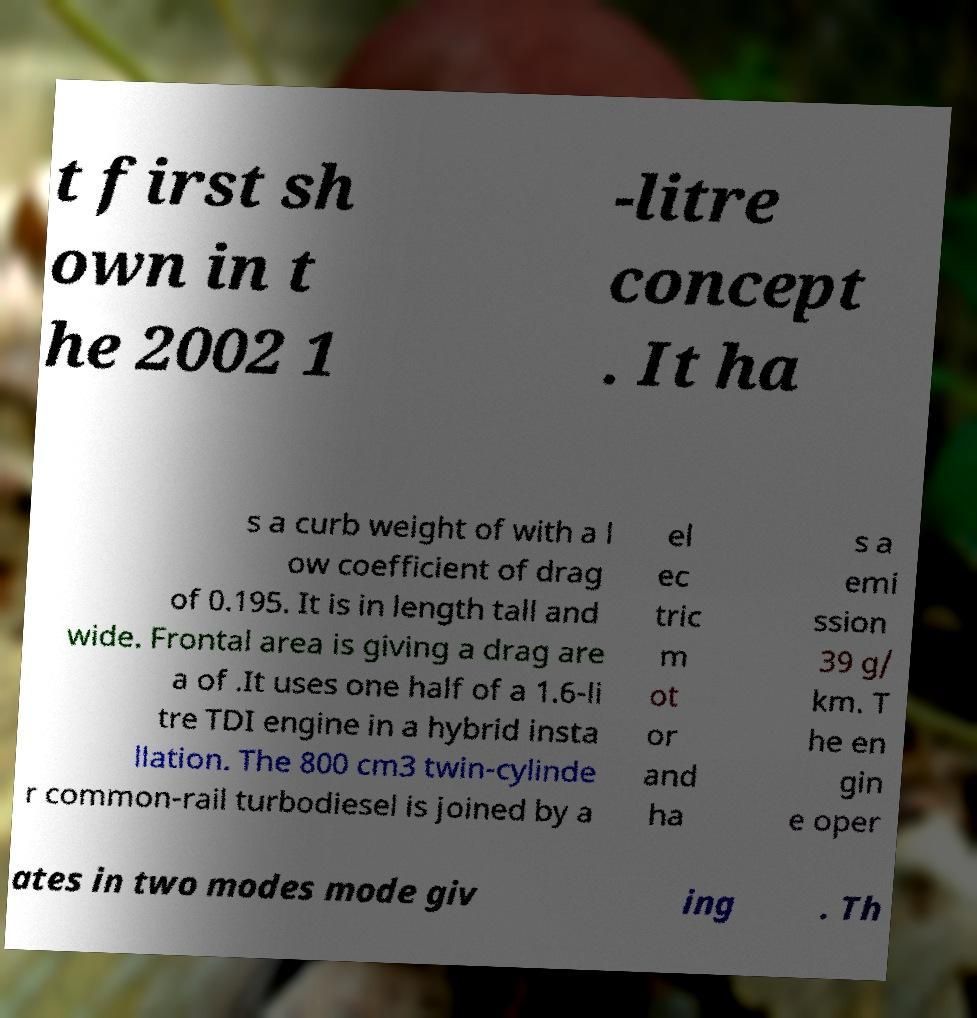Could you extract and type out the text from this image? t first sh own in t he 2002 1 -litre concept . It ha s a curb weight of with a l ow coefficient of drag of 0.195. It is in length tall and wide. Frontal area is giving a drag are a of .It uses one half of a 1.6-li tre TDI engine in a hybrid insta llation. The 800 cm3 twin-cylinde r common-rail turbodiesel is joined by a el ec tric m ot or and ha s a emi ssion 39 g/ km. T he en gin e oper ates in two modes mode giv ing . Th 